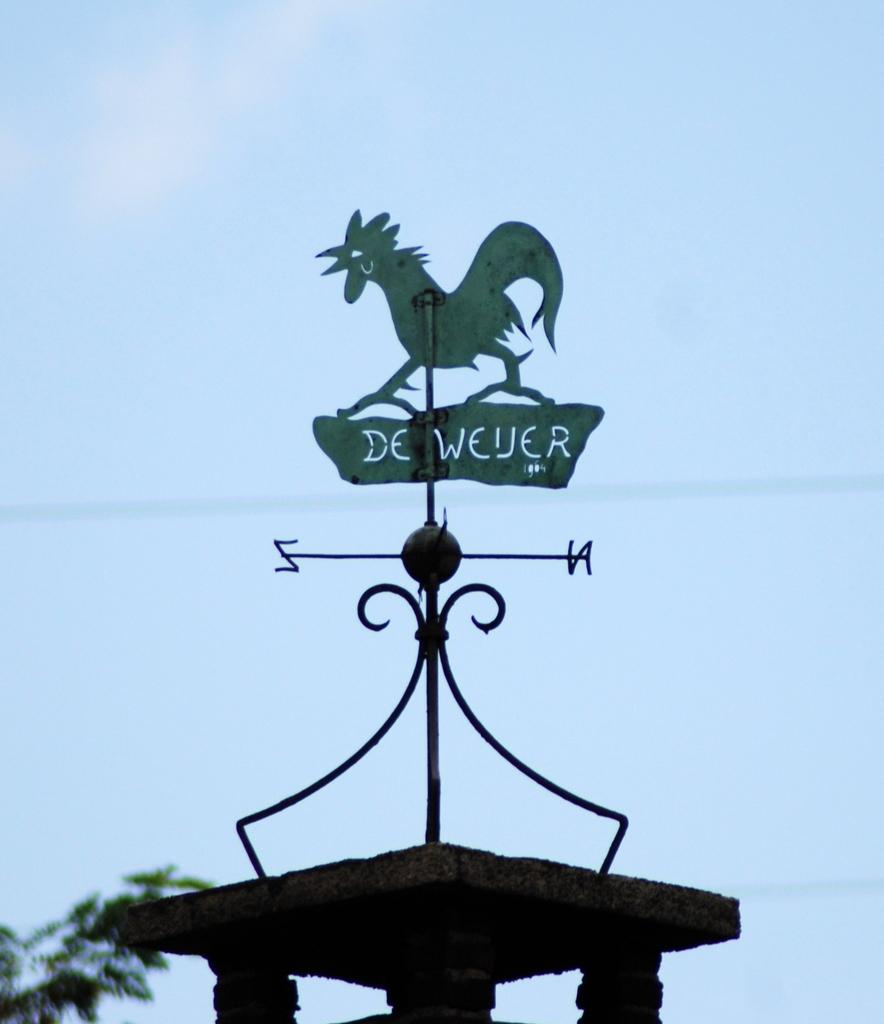What is the main object in the image? There is a pole in the image. What is attached to the pole? There is a board of a bird on the pole. What can be seen in the background of the image? There are trees and a blue sky in the background of the image. What type of meal is being prepared on the pole in the image? There is no meal being prepared in the image; it features a pole with a board of a bird. What is the way the beetle is climbing on the pole in the image? There is no beetle present in the image; it only features a pole with a board of a bird. 